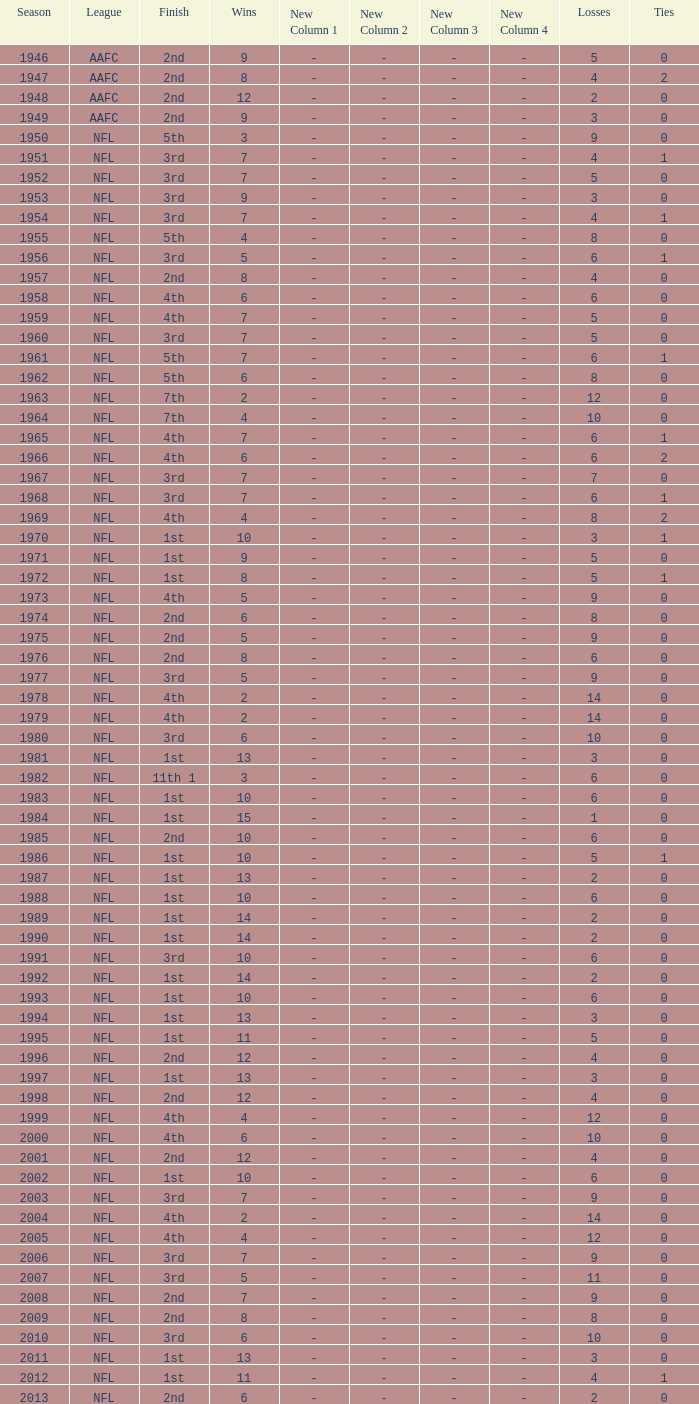What is the losses in the NFL in the 2011 season with less than 13 wins? None. 